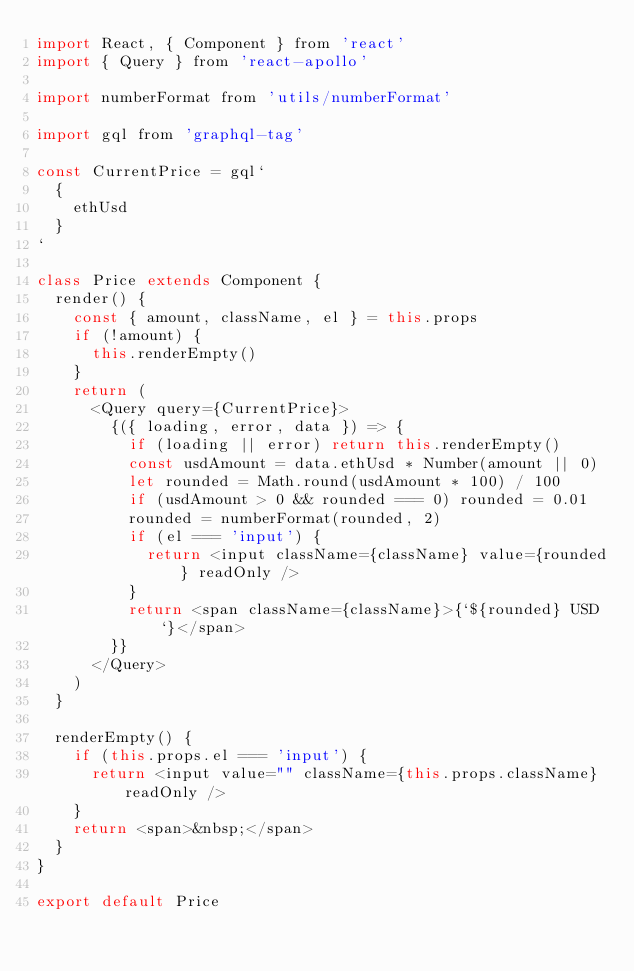Convert code to text. <code><loc_0><loc_0><loc_500><loc_500><_JavaScript_>import React, { Component } from 'react'
import { Query } from 'react-apollo'

import numberFormat from 'utils/numberFormat'

import gql from 'graphql-tag'

const CurrentPrice = gql`
  {
    ethUsd
  }
`

class Price extends Component {
  render() {
    const { amount, className, el } = this.props
    if (!amount) {
      this.renderEmpty()
    }
    return (
      <Query query={CurrentPrice}>
        {({ loading, error, data }) => {
          if (loading || error) return this.renderEmpty()
          const usdAmount = data.ethUsd * Number(amount || 0)
          let rounded = Math.round(usdAmount * 100) / 100
          if (usdAmount > 0 && rounded === 0) rounded = 0.01
          rounded = numberFormat(rounded, 2)
          if (el === 'input') {
            return <input className={className} value={rounded} readOnly />
          }
          return <span className={className}>{`${rounded} USD`}</span>
        }}
      </Query>
    )
  }

  renderEmpty() {
    if (this.props.el === 'input') {
      return <input value="" className={this.props.className} readOnly />
    }
    return <span>&nbsp;</span>
  }
}

export default Price
</code> 